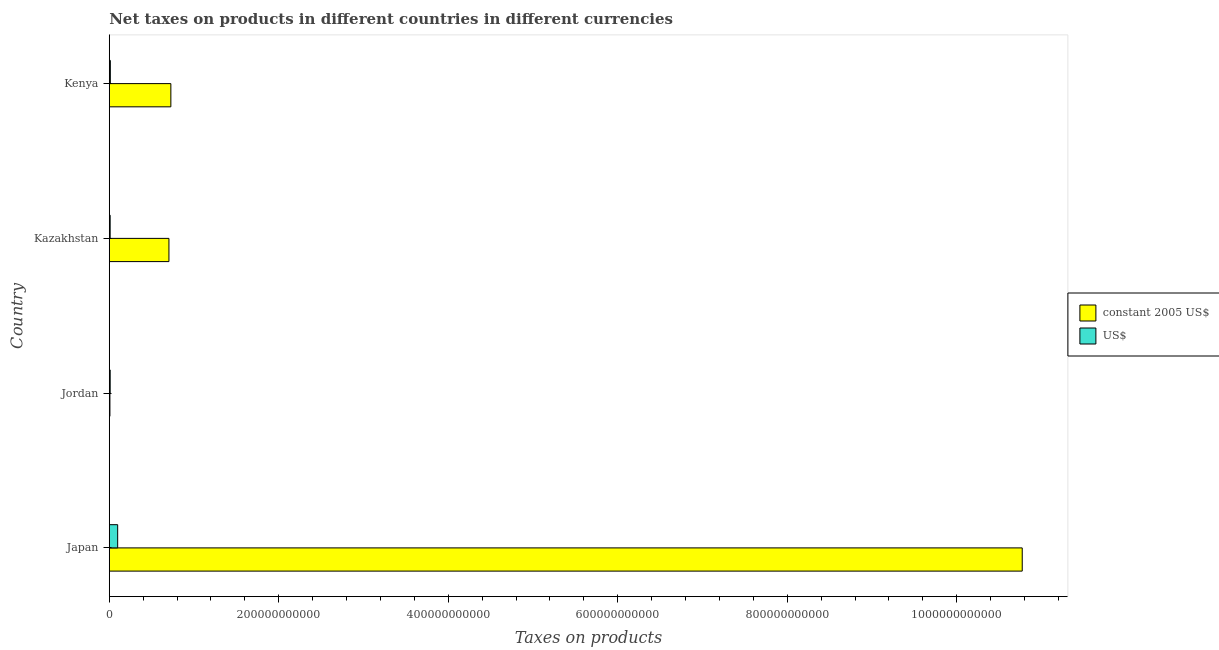How many groups of bars are there?
Your answer should be very brief. 4. Are the number of bars per tick equal to the number of legend labels?
Ensure brevity in your answer.  Yes. How many bars are there on the 4th tick from the bottom?
Provide a succinct answer. 2. In how many cases, is the number of bars for a given country not equal to the number of legend labels?
Provide a succinct answer. 0. What is the net taxes in constant 2005 us$ in Jordan?
Your answer should be very brief. 7.69e+08. Across all countries, what is the maximum net taxes in us$?
Give a very brief answer. 9.90e+09. Across all countries, what is the minimum net taxes in constant 2005 us$?
Ensure brevity in your answer.  7.69e+08. In which country was the net taxes in us$ maximum?
Your answer should be compact. Japan. In which country was the net taxes in us$ minimum?
Your answer should be compact. Kazakhstan. What is the total net taxes in constant 2005 us$ in the graph?
Ensure brevity in your answer.  1.22e+12. What is the difference between the net taxes in us$ in Jordan and that in Kenya?
Keep it short and to the point. -1.88e+08. What is the difference between the net taxes in us$ in Japan and the net taxes in constant 2005 us$ in Kazakhstan?
Your response must be concise. -6.05e+1. What is the average net taxes in constant 2005 us$ per country?
Your answer should be very brief. 3.05e+11. What is the difference between the net taxes in us$ and net taxes in constant 2005 us$ in Kenya?
Ensure brevity in your answer.  -7.14e+1. In how many countries, is the net taxes in constant 2005 us$ greater than 200000000000 units?
Offer a very short reply. 1. What is the ratio of the net taxes in constant 2005 us$ in Jordan to that in Kenya?
Give a very brief answer. 0.01. Is the difference between the net taxes in us$ in Japan and Kenya greater than the difference between the net taxes in constant 2005 us$ in Japan and Kenya?
Provide a short and direct response. No. What is the difference between the highest and the second highest net taxes in us$?
Give a very brief answer. 8.63e+09. What is the difference between the highest and the lowest net taxes in us$?
Provide a succinct answer. 8.86e+09. What does the 1st bar from the top in Japan represents?
Offer a very short reply. US$. What does the 1st bar from the bottom in Kazakhstan represents?
Your answer should be compact. Constant 2005 us$. How many bars are there?
Offer a terse response. 8. What is the difference between two consecutive major ticks on the X-axis?
Keep it short and to the point. 2.00e+11. Are the values on the major ticks of X-axis written in scientific E-notation?
Give a very brief answer. No. Does the graph contain grids?
Offer a terse response. No. Where does the legend appear in the graph?
Give a very brief answer. Center right. What is the title of the graph?
Provide a short and direct response. Net taxes on products in different countries in different currencies. What is the label or title of the X-axis?
Ensure brevity in your answer.  Taxes on products. What is the label or title of the Y-axis?
Your response must be concise. Country. What is the Taxes on products in constant 2005 US$ in Japan?
Your answer should be compact. 1.08e+12. What is the Taxes on products of US$ in Japan?
Make the answer very short. 9.90e+09. What is the Taxes on products in constant 2005 US$ in Jordan?
Provide a succinct answer. 7.69e+08. What is the Taxes on products of US$ in Jordan?
Ensure brevity in your answer.  1.08e+09. What is the Taxes on products in constant 2005 US$ in Kazakhstan?
Provide a short and direct response. 7.04e+1. What is the Taxes on products in US$ in Kazakhstan?
Your answer should be compact. 1.05e+09. What is the Taxes on products of constant 2005 US$ in Kenya?
Keep it short and to the point. 7.27e+1. What is the Taxes on products of US$ in Kenya?
Make the answer very short. 1.27e+09. Across all countries, what is the maximum Taxes on products in constant 2005 US$?
Your answer should be very brief. 1.08e+12. Across all countries, what is the maximum Taxes on products of US$?
Your response must be concise. 9.90e+09. Across all countries, what is the minimum Taxes on products of constant 2005 US$?
Your answer should be compact. 7.69e+08. Across all countries, what is the minimum Taxes on products of US$?
Offer a terse response. 1.05e+09. What is the total Taxes on products of constant 2005 US$ in the graph?
Make the answer very short. 1.22e+12. What is the total Taxes on products of US$ in the graph?
Your response must be concise. 1.33e+1. What is the difference between the Taxes on products of constant 2005 US$ in Japan and that in Jordan?
Offer a very short reply. 1.08e+12. What is the difference between the Taxes on products in US$ in Japan and that in Jordan?
Offer a terse response. 8.82e+09. What is the difference between the Taxes on products in constant 2005 US$ in Japan and that in Kazakhstan?
Ensure brevity in your answer.  1.01e+12. What is the difference between the Taxes on products of US$ in Japan and that in Kazakhstan?
Your response must be concise. 8.86e+09. What is the difference between the Taxes on products in constant 2005 US$ in Japan and that in Kenya?
Give a very brief answer. 1.00e+12. What is the difference between the Taxes on products in US$ in Japan and that in Kenya?
Keep it short and to the point. 8.63e+09. What is the difference between the Taxes on products of constant 2005 US$ in Jordan and that in Kazakhstan?
Keep it short and to the point. -6.96e+1. What is the difference between the Taxes on products in US$ in Jordan and that in Kazakhstan?
Provide a short and direct response. 3.81e+07. What is the difference between the Taxes on products of constant 2005 US$ in Jordan and that in Kenya?
Your answer should be very brief. -7.19e+1. What is the difference between the Taxes on products of US$ in Jordan and that in Kenya?
Provide a short and direct response. -1.88e+08. What is the difference between the Taxes on products of constant 2005 US$ in Kazakhstan and that in Kenya?
Your response must be concise. -2.26e+09. What is the difference between the Taxes on products in US$ in Kazakhstan and that in Kenya?
Your answer should be very brief. -2.26e+08. What is the difference between the Taxes on products in constant 2005 US$ in Japan and the Taxes on products in US$ in Jordan?
Offer a terse response. 1.08e+12. What is the difference between the Taxes on products in constant 2005 US$ in Japan and the Taxes on products in US$ in Kazakhstan?
Offer a terse response. 1.08e+12. What is the difference between the Taxes on products in constant 2005 US$ in Japan and the Taxes on products in US$ in Kenya?
Give a very brief answer. 1.08e+12. What is the difference between the Taxes on products of constant 2005 US$ in Jordan and the Taxes on products of US$ in Kazakhstan?
Make the answer very short. -2.77e+08. What is the difference between the Taxes on products of constant 2005 US$ in Jordan and the Taxes on products of US$ in Kenya?
Keep it short and to the point. -5.04e+08. What is the difference between the Taxes on products in constant 2005 US$ in Kazakhstan and the Taxes on products in US$ in Kenya?
Provide a short and direct response. 6.91e+1. What is the average Taxes on products in constant 2005 US$ per country?
Keep it short and to the point. 3.05e+11. What is the average Taxes on products of US$ per country?
Offer a very short reply. 3.33e+09. What is the difference between the Taxes on products in constant 2005 US$ and Taxes on products in US$ in Japan?
Provide a succinct answer. 1.07e+12. What is the difference between the Taxes on products of constant 2005 US$ and Taxes on products of US$ in Jordan?
Give a very brief answer. -3.16e+08. What is the difference between the Taxes on products in constant 2005 US$ and Taxes on products in US$ in Kazakhstan?
Provide a short and direct response. 6.94e+1. What is the difference between the Taxes on products in constant 2005 US$ and Taxes on products in US$ in Kenya?
Give a very brief answer. 7.14e+1. What is the ratio of the Taxes on products in constant 2005 US$ in Japan to that in Jordan?
Make the answer very short. 1401.45. What is the ratio of the Taxes on products in US$ in Japan to that in Jordan?
Your answer should be compact. 9.13. What is the ratio of the Taxes on products of constant 2005 US$ in Japan to that in Kazakhstan?
Make the answer very short. 15.3. What is the ratio of the Taxes on products in US$ in Japan to that in Kazakhstan?
Make the answer very short. 9.47. What is the ratio of the Taxes on products in constant 2005 US$ in Japan to that in Kenya?
Ensure brevity in your answer.  14.83. What is the ratio of the Taxes on products of US$ in Japan to that in Kenya?
Your answer should be compact. 7.78. What is the ratio of the Taxes on products of constant 2005 US$ in Jordan to that in Kazakhstan?
Offer a terse response. 0.01. What is the ratio of the Taxes on products in US$ in Jordan to that in Kazakhstan?
Your response must be concise. 1.04. What is the ratio of the Taxes on products of constant 2005 US$ in Jordan to that in Kenya?
Provide a succinct answer. 0.01. What is the ratio of the Taxes on products of US$ in Jordan to that in Kenya?
Offer a terse response. 0.85. What is the ratio of the Taxes on products of constant 2005 US$ in Kazakhstan to that in Kenya?
Your answer should be very brief. 0.97. What is the ratio of the Taxes on products of US$ in Kazakhstan to that in Kenya?
Ensure brevity in your answer.  0.82. What is the difference between the highest and the second highest Taxes on products in constant 2005 US$?
Offer a very short reply. 1.00e+12. What is the difference between the highest and the second highest Taxes on products in US$?
Your response must be concise. 8.63e+09. What is the difference between the highest and the lowest Taxes on products in constant 2005 US$?
Your response must be concise. 1.08e+12. What is the difference between the highest and the lowest Taxes on products of US$?
Make the answer very short. 8.86e+09. 